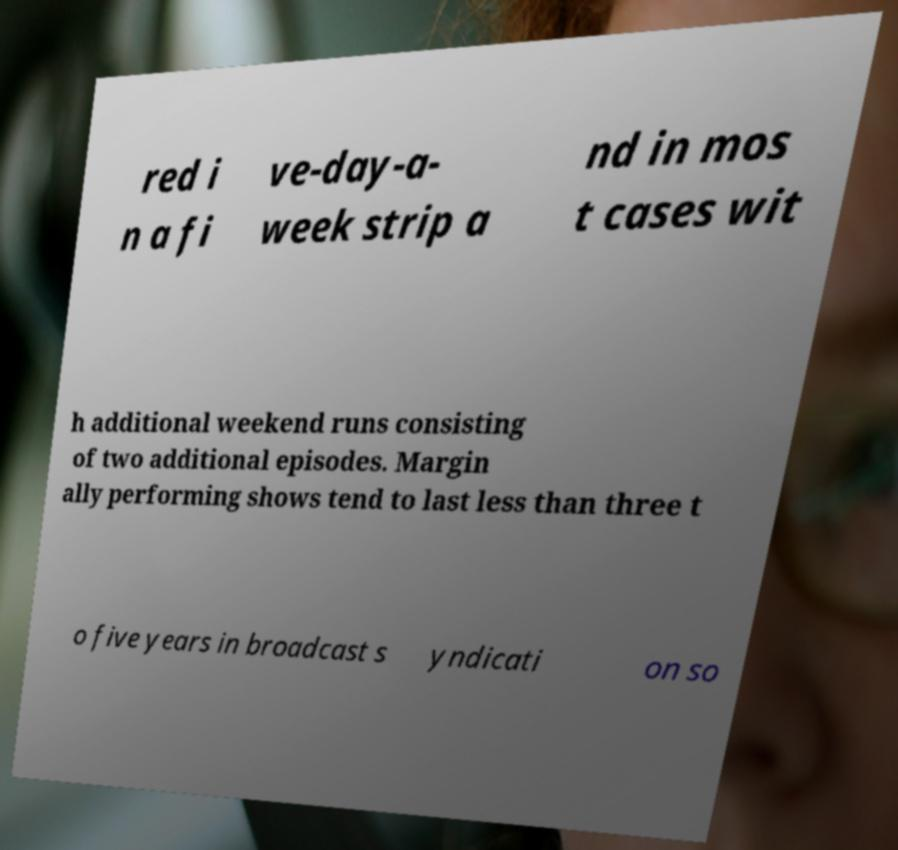Can you read and provide the text displayed in the image?This photo seems to have some interesting text. Can you extract and type it out for me? red i n a fi ve-day-a- week strip a nd in mos t cases wit h additional weekend runs consisting of two additional episodes. Margin ally performing shows tend to last less than three t o five years in broadcast s yndicati on so 